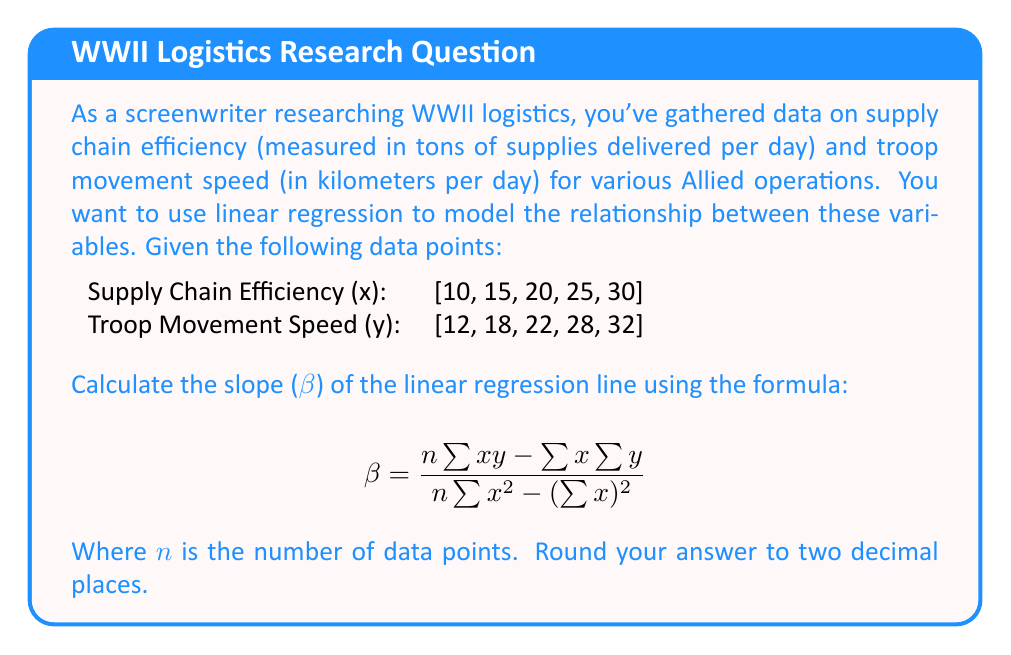Could you help me with this problem? Let's approach this step-by-step:

1) First, we need to calculate the following values:
   n = 5 (number of data points)
   $\sum{x}$ = 10 + 15 + 20 + 25 + 30 = 100
   $\sum{y}$ = 12 + 18 + 22 + 28 + 32 = 112
   $\sum{xy}$ = (10×12) + (15×18) + (20×22) + (25×28) + (30×32) = 2,620
   $\sum{x^2}$ = 10² + 15² + 20² + 25² + 30² = 2,250
   $(\sum{x})^2$ = 100² = 10,000

2) Now, let's substitute these values into the formula:

   $$ \beta = \frac{5(2,620) - (100)(112)}{5(2,250) - (10,000)} $$

3) Simplify the numerator and denominator:

   $$ \beta = \frac{13,100 - 11,200}{11,250 - 10,000} $$

4) Calculate:

   $$ \beta = \frac{1,900}{1,250} = 1.52 $$

5) Rounding to two decimal places:

   $$ \beta = 1.52 $$

This slope indicates that for every one-unit increase in supply chain efficiency, we expect troop movement speed to increase by 1.52 kilometers per day, on average.
Answer: 1.52 